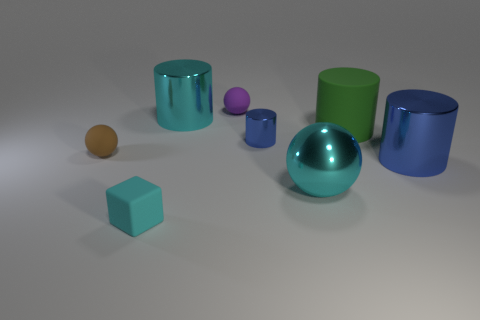How many tiny purple spheres are right of the shiny cylinder in front of the tiny object to the right of the purple object? 0 